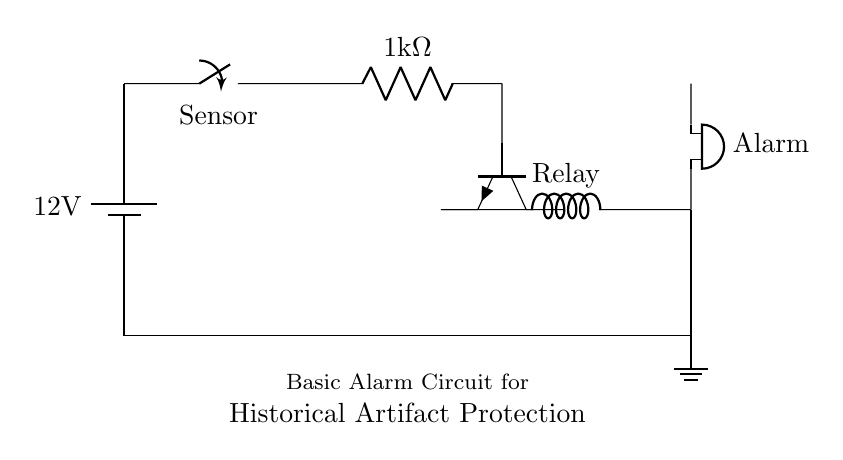What is the voltage of this circuit? The voltage is 12 volts, which is indicated by the battery symbol at the top left of the circuit diagram.
Answer: 12 volts What component is used as a sensor? The component labeled "Sensor" in the circuit is a switch, specifically a normally closed switch, which is used to detect unauthorized access.
Answer: Switch How many ohms is the resistor in this circuit? The resistor is labeled as 1 kilohm in the circuit diagram, specifying the resistance value of this component.
Answer: 1 kilohm What type of transistor is shown in the diagram? The diagram shows an NPN transistor, indicated by the specific symbol used for npn transistors, which is oriented in a certain way with the collector, base, and emitter terminals.
Answer: NPN What action does the alarm perform when activated? The alarm produces sound when the circuit is activated, indicated by the buzzer symbol connected to the relay coil, showing that it will alert when triggered.
Answer: Sound What is the purpose of the relay in this circuit? The relay is used to control the alarm activation, allowing a low-power signal from the transistor's output to switch a higher power load for the alarm, providing isolation and control of the alarm system.
Answer: Control alarm What is the connection type of the sensor in the circuit? The sensor is connected as a normally closed switch, meaning it allows current to flow under normal conditions but will open the circuit and stop the current when activated.
Answer: Normally closed 